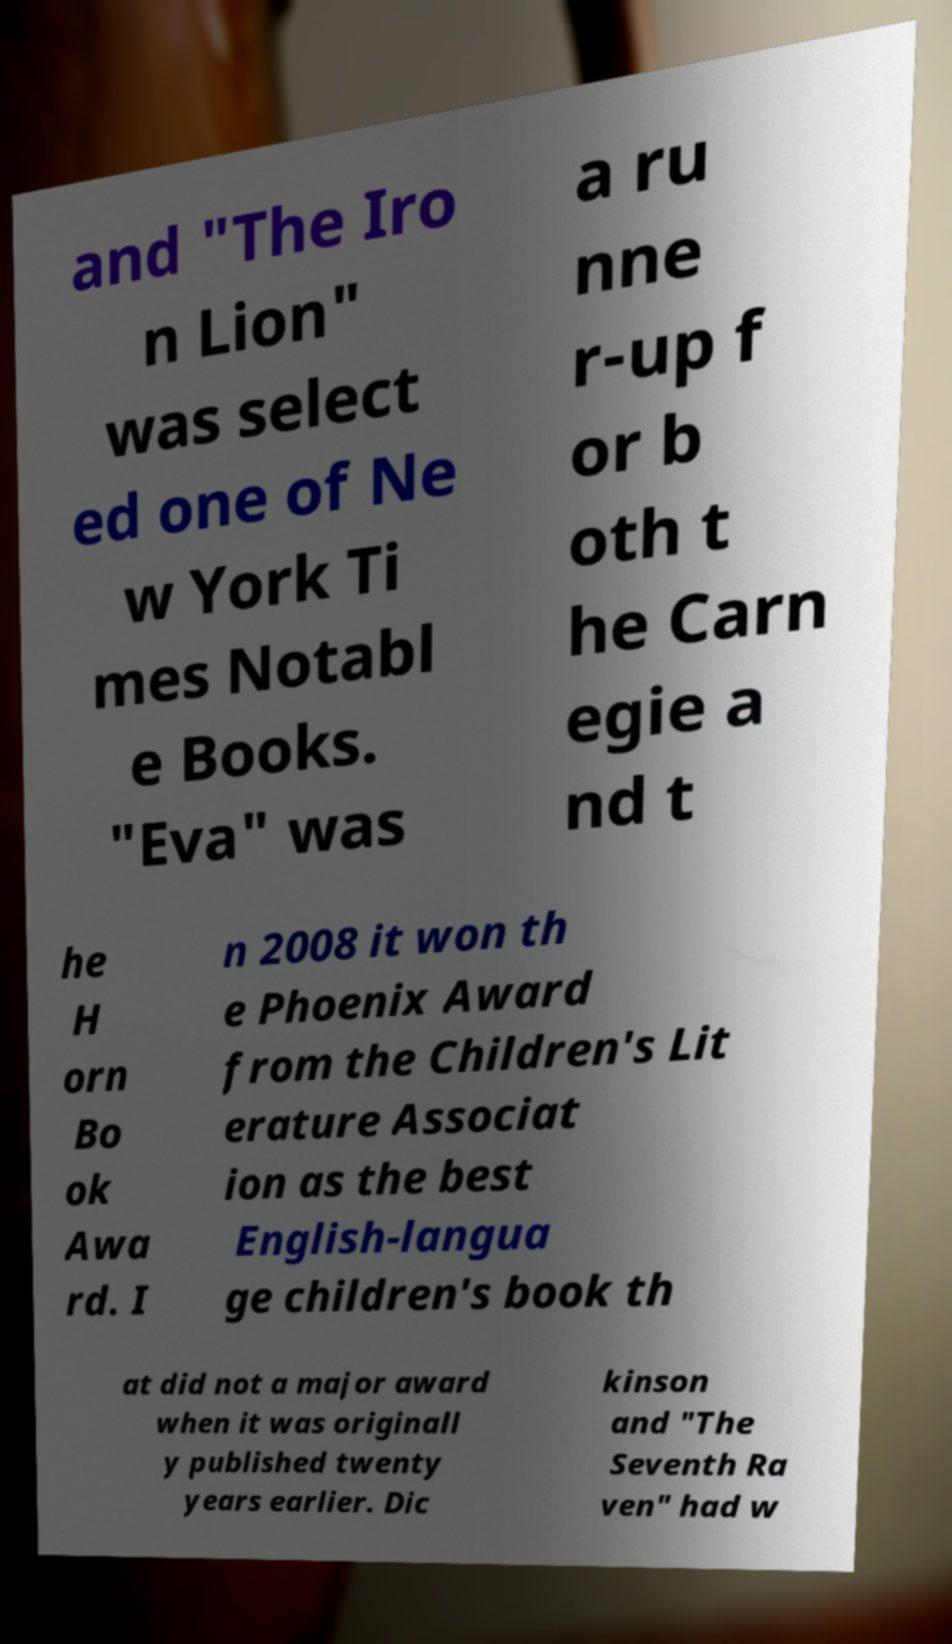Please read and relay the text visible in this image. What does it say? and "The Iro n Lion" was select ed one of Ne w York Ti mes Notabl e Books. "Eva" was a ru nne r-up f or b oth t he Carn egie a nd t he H orn Bo ok Awa rd. I n 2008 it won th e Phoenix Award from the Children's Lit erature Associat ion as the best English-langua ge children's book th at did not a major award when it was originall y published twenty years earlier. Dic kinson and "The Seventh Ra ven" had w 